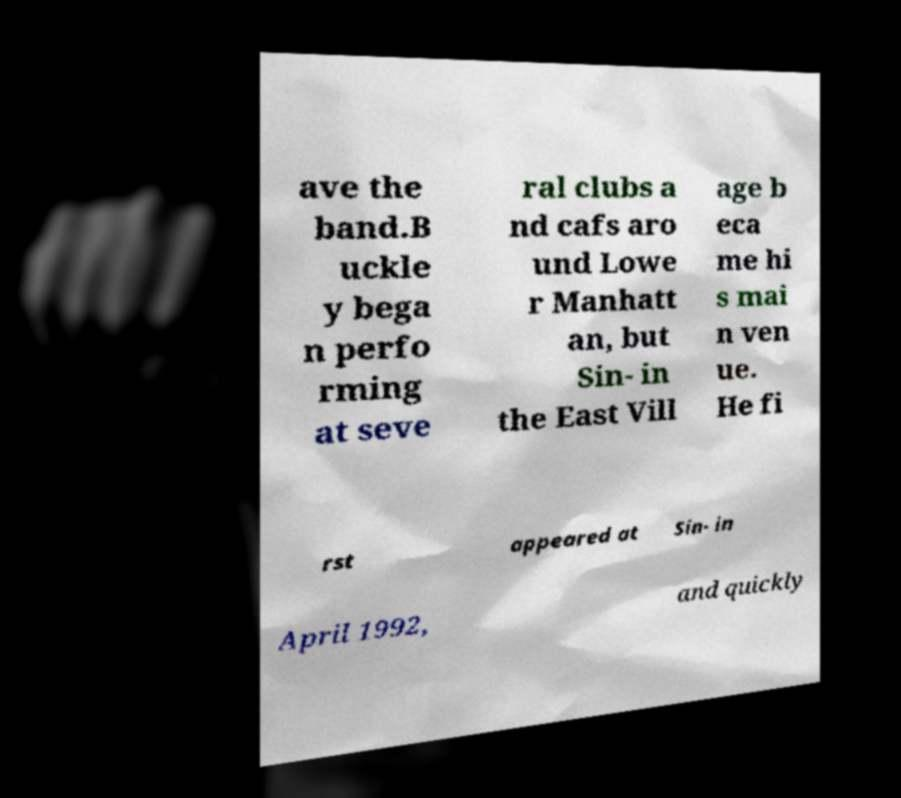Please read and relay the text visible in this image. What does it say? ave the band.B uckle y bega n perfo rming at seve ral clubs a nd cafs aro und Lowe r Manhatt an, but Sin- in the East Vill age b eca me hi s mai n ven ue. He fi rst appeared at Sin- in April 1992, and quickly 